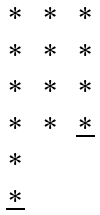<formula> <loc_0><loc_0><loc_500><loc_500>\begin{matrix} * & * & * \\ * & * & * \\ * & * & * \\ * & * & \underline { * } \\ * & & \\ \underline { * } & & \end{matrix}</formula> 